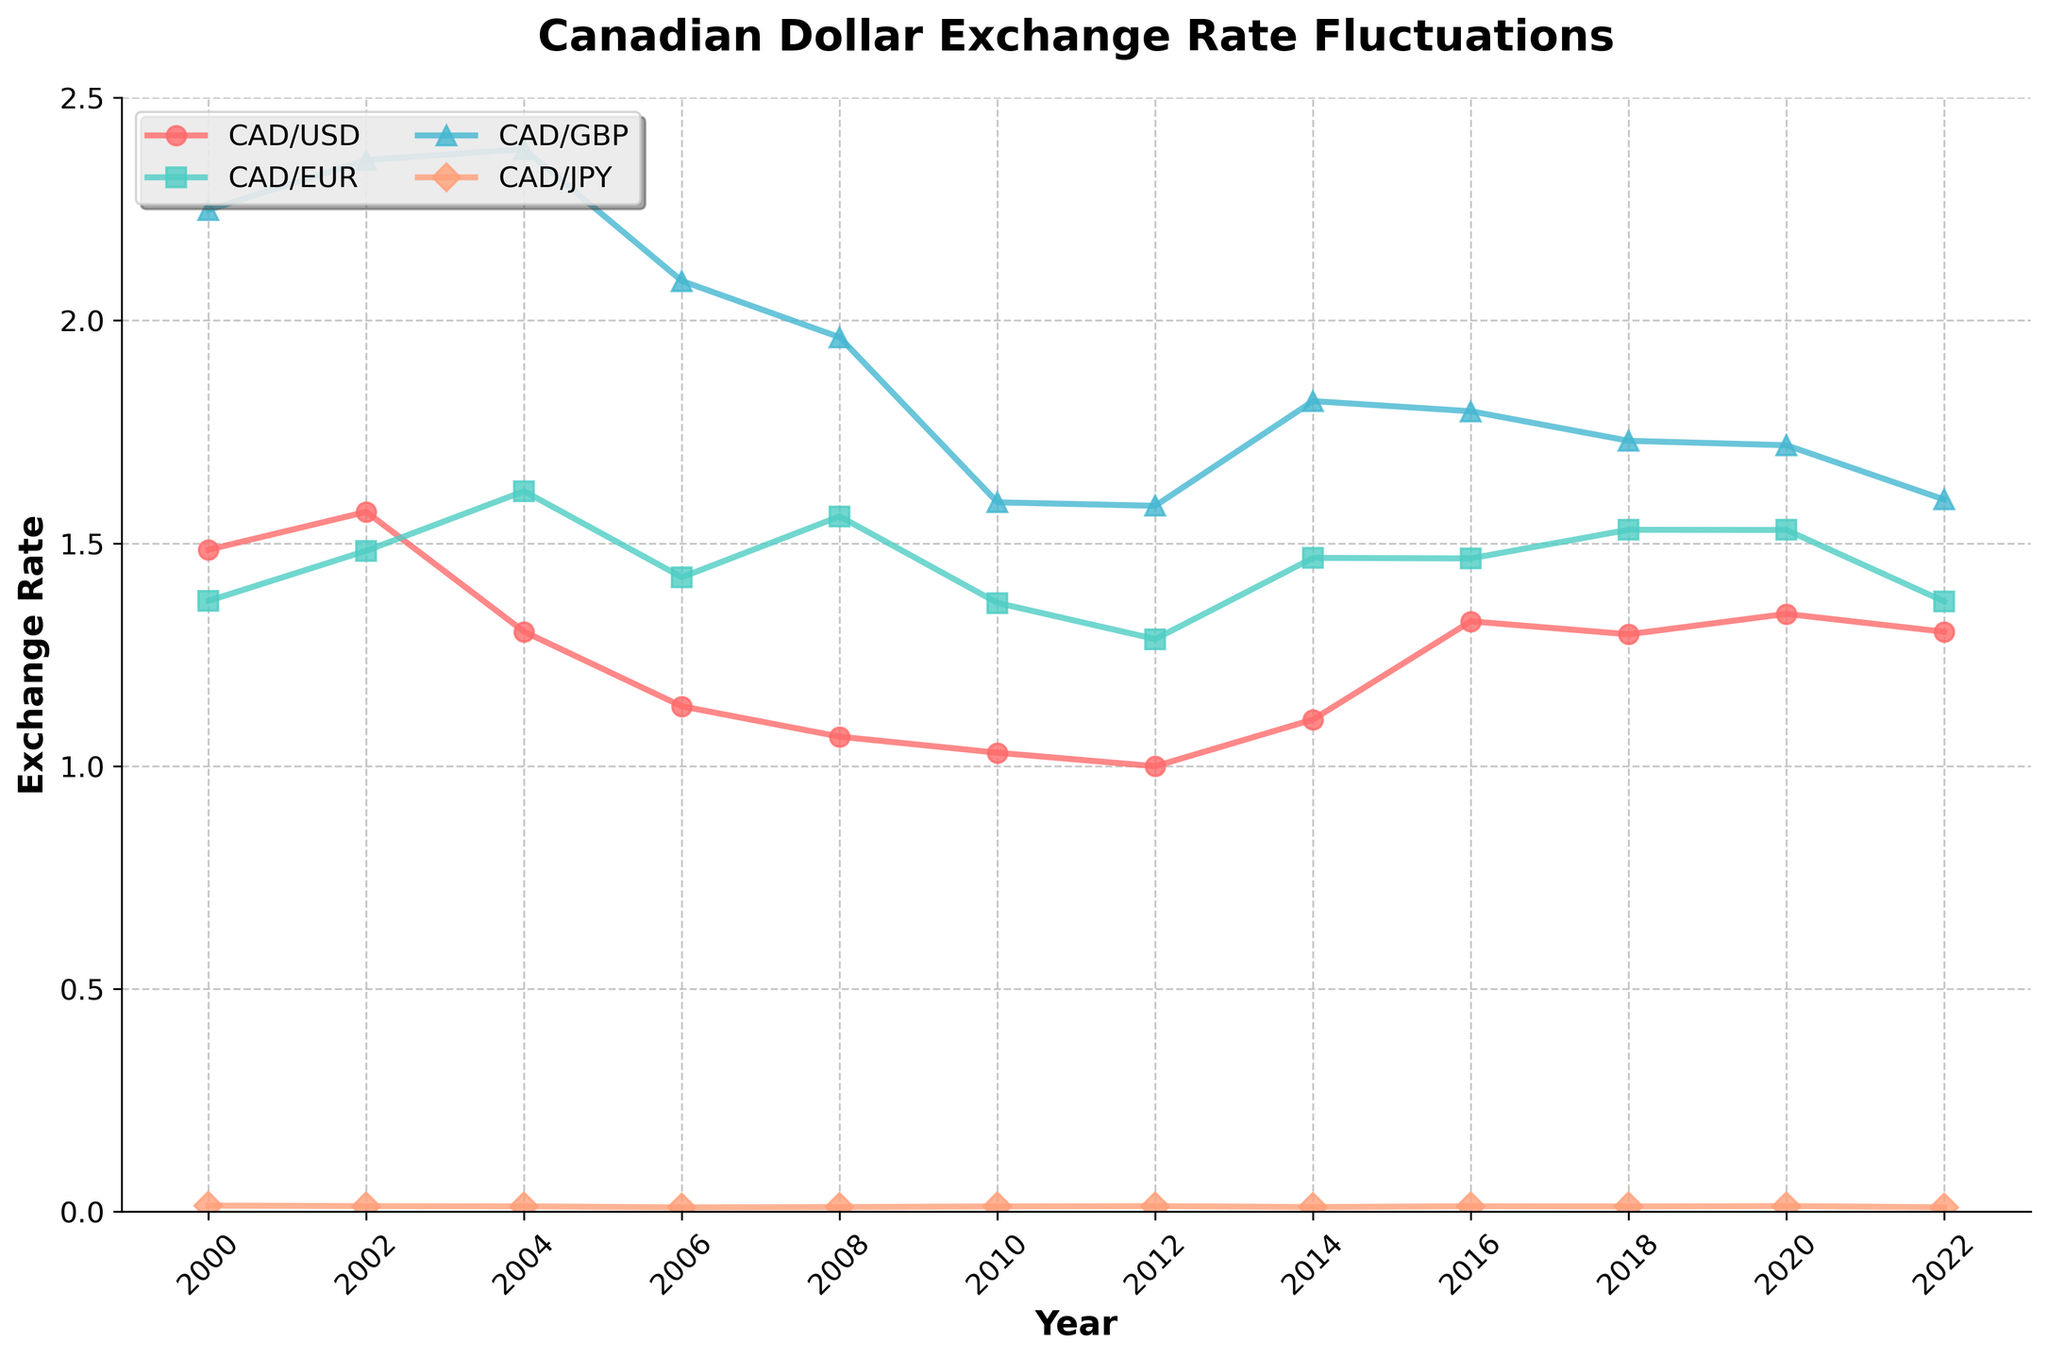What's the trend of the CAD/USD exchange rate from 2000 to 2022? Start by noting the CAD/USD values in 2000 (1.4855) and 2022 (1.3013). The exchange rate decreases initially to 1.0299 in 2010, then rises and fluctuates until 2022. The general trend indicates a slight decrease.
Answer: Slight decrease Which currency had the most stable exchange rate with CAD from 2000 to 2022? Examine the CAD/USD, CAD/EUR, CAD/GBP, and CAD/JPY lines. 'Most stable' implies minimal fluctuations. The CAD/JPY line shows the least fluctuation over time.
Answer: CAD/JPY In which year did the CAD/USD exchange rate reach its lowest point? Check the CAD/USD line for the lowest point from 2000 to 2022. It reached its lowest in 2012 at 0.9996.
Answer: 2012 How did the CAD/EUR exchange rate change from 2002 to 2006? Note CAD/EUR in 2002 (1.4832) and 2006 (1.4237). The rate decreased by 0.0595 units.
Answer: Decreased What was the difference in the CAD/GBP exchange rate between 2008 and 2018? CAD/GBP in 2008 was 1.9621 and 1.7299 in 2018. Subtract 1.7299 from 1.9621 to get 0.2322.
Answer: 0.2322 Comparing 2020 and 2022, how did the CAD/USD exchange rate change? The CAD/USD rate in 2020 was 1.3415 and 1.3013 in 2022. The rate decreased by 0.0402.
Answer: Decreased by 0.0402 Which year showed the peak for CAD/GBP? Checking the CAD/GBP line visually, it peaks around 2004 with a value of 2.3845.
Answer: 2004 By how much did the CAD/EUR rate change from 2000 to 2022? Subtract CAD/EUR in 2000 (1.3707) from its value in 2022 (1.3695), resulting in a difference of 0.0012 units.
Answer: 0.0012 What is the average CAD/USD exchange rate over the years provided? Sum up all CAD/USD values from 2000 to 2022 and divide by the number of years (12). The calculation \( (1.4855 + 1.5704 + 1.3015 + 1.1341 + 1.0660 + 1.0299 + 0.9996 + 1.1045 + 1.3248 + 1.2957 + 1.3415 + 1.3013) / 12 = 1.2395 \)
Answer: 1.2395 